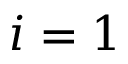<formula> <loc_0><loc_0><loc_500><loc_500>i = 1</formula> 